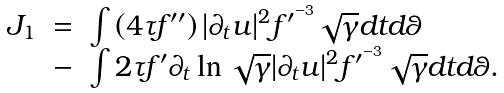<formula> <loc_0><loc_0><loc_500><loc_500>\begin{array} { r c l } J _ { 1 } & = & \int \left ( 4 \tau f ^ { \prime \prime } \right ) | \partial _ { t } u | ^ { 2 } f ^ { \prime ^ { - 3 } } \sqrt { \gamma } d t d \theta \\ & - & \int 2 \tau f ^ { \prime } \partial _ { t } \ln \sqrt { \gamma } | \partial _ { t } u | ^ { 2 } f ^ { \prime ^ { - 3 } } \sqrt { \gamma } d t d \theta . \end{array}</formula> 